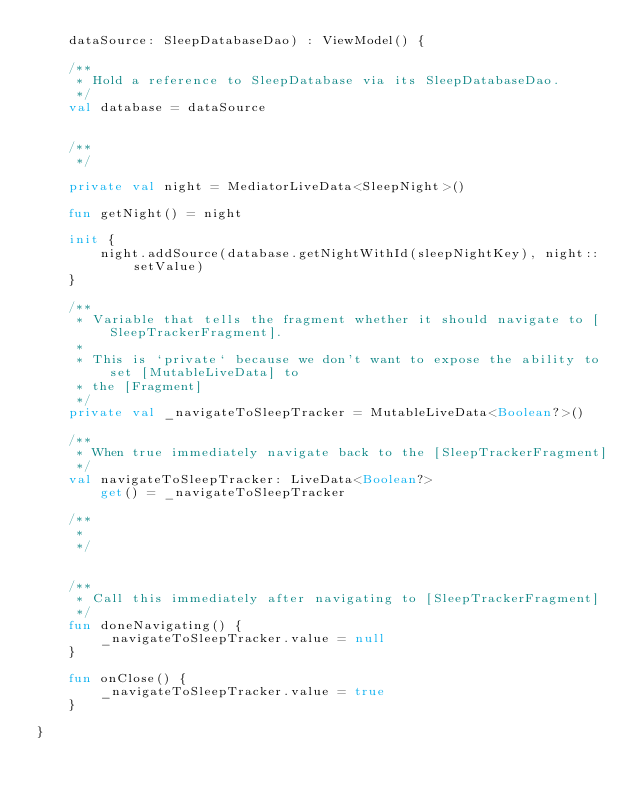Convert code to text. <code><loc_0><loc_0><loc_500><loc_500><_Kotlin_>    dataSource: SleepDatabaseDao) : ViewModel() {

    /**
     * Hold a reference to SleepDatabase via its SleepDatabaseDao.
     */
    val database = dataSource


    /**
     */

    private val night = MediatorLiveData<SleepNight>()

    fun getNight() = night

    init {
        night.addSource(database.getNightWithId(sleepNightKey), night::setValue)
    }

    /**
     * Variable that tells the fragment whether it should navigate to [SleepTrackerFragment].
     *
     * This is `private` because we don't want to expose the ability to set [MutableLiveData] to
     * the [Fragment]
     */
    private val _navigateToSleepTracker = MutableLiveData<Boolean?>()

    /**
     * When true immediately navigate back to the [SleepTrackerFragment]
     */
    val navigateToSleepTracker: LiveData<Boolean?>
        get() = _navigateToSleepTracker

    /**
     *
     */


    /**
     * Call this immediately after navigating to [SleepTrackerFragment]
     */
    fun doneNavigating() {
        _navigateToSleepTracker.value = null
    }

    fun onClose() {
        _navigateToSleepTracker.value = true
    }

}

</code> 